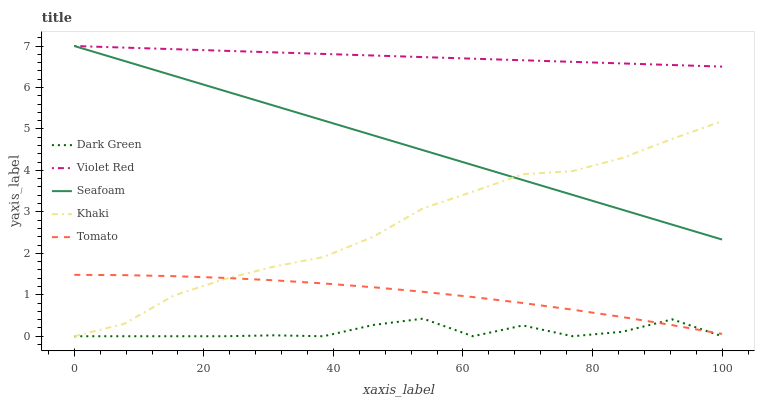Does Dark Green have the minimum area under the curve?
Answer yes or no. Yes. Does Violet Red have the maximum area under the curve?
Answer yes or no. Yes. Does Khaki have the minimum area under the curve?
Answer yes or no. No. Does Khaki have the maximum area under the curve?
Answer yes or no. No. Is Violet Red the smoothest?
Answer yes or no. Yes. Is Dark Green the roughest?
Answer yes or no. Yes. Is Khaki the smoothest?
Answer yes or no. No. Is Khaki the roughest?
Answer yes or no. No. Does Khaki have the lowest value?
Answer yes or no. Yes. Does Violet Red have the lowest value?
Answer yes or no. No. Does Seafoam have the highest value?
Answer yes or no. Yes. Does Khaki have the highest value?
Answer yes or no. No. Is Tomato less than Seafoam?
Answer yes or no. Yes. Is Violet Red greater than Khaki?
Answer yes or no. Yes. Does Tomato intersect Khaki?
Answer yes or no. Yes. Is Tomato less than Khaki?
Answer yes or no. No. Is Tomato greater than Khaki?
Answer yes or no. No. Does Tomato intersect Seafoam?
Answer yes or no. No. 